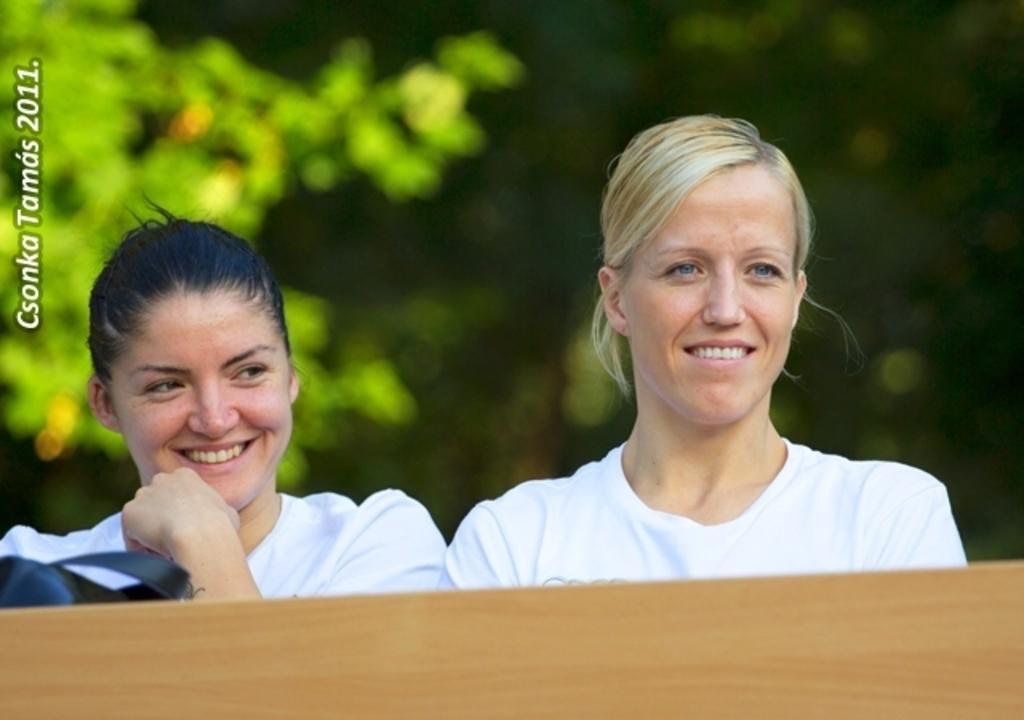Describe this image in one or two sentences. There are two women, it seems like a table in the foreground area of the image, there is text on the left side and greenery in the background. 